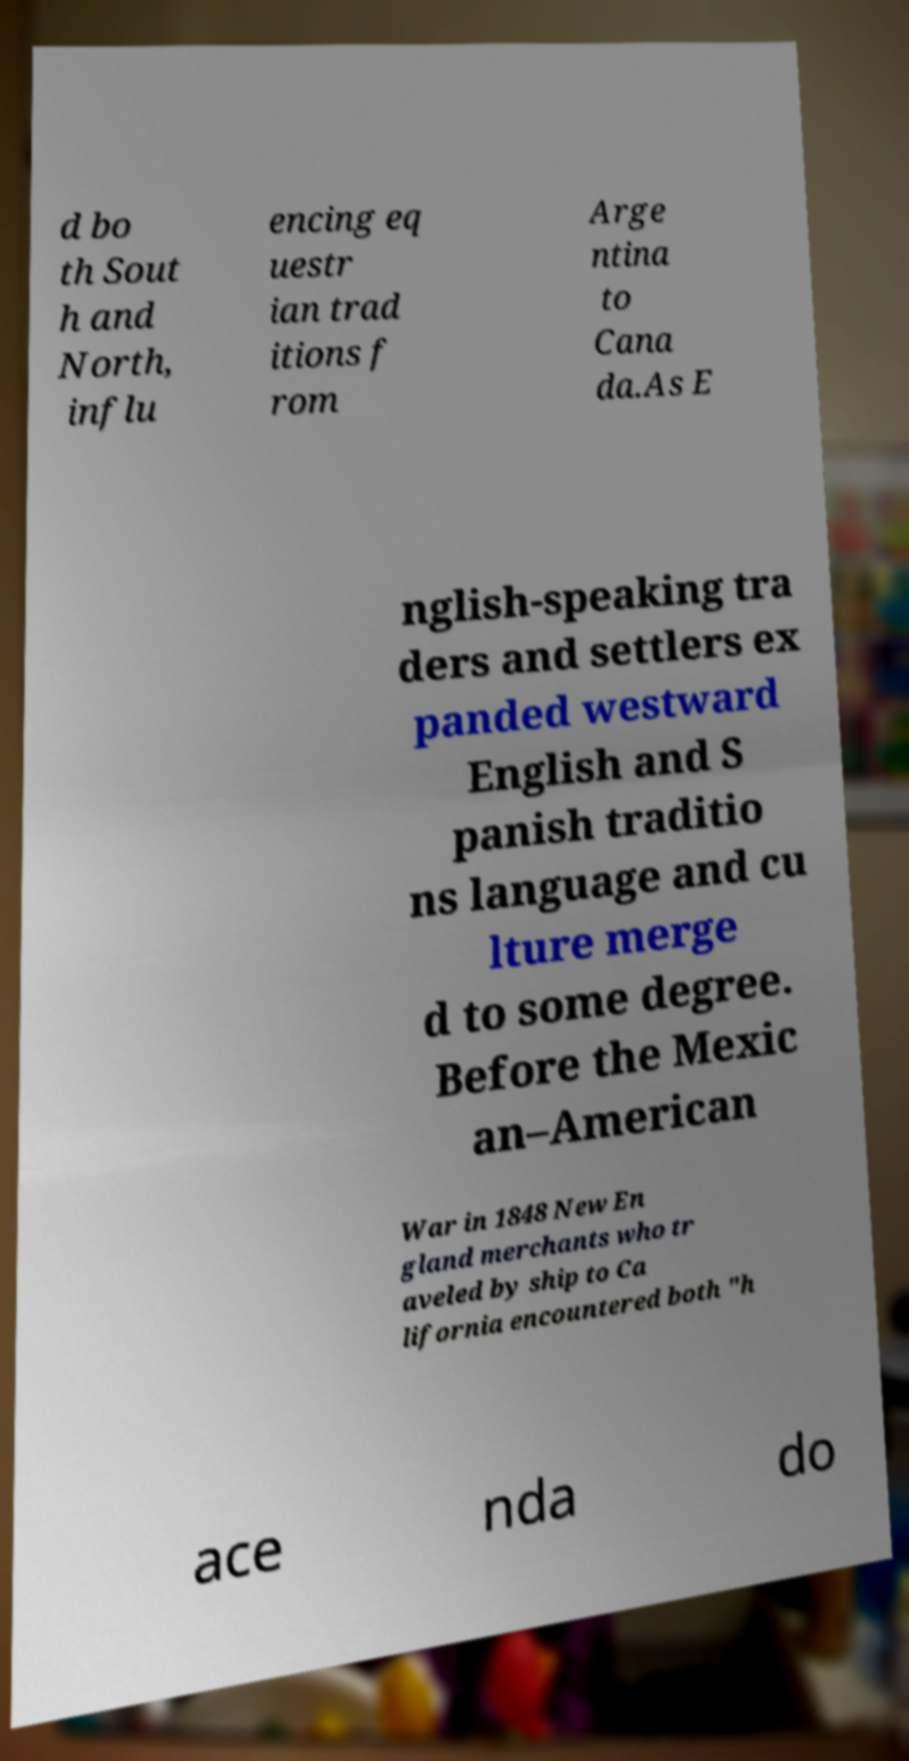Please identify and transcribe the text found in this image. d bo th Sout h and North, influ encing eq uestr ian trad itions f rom Arge ntina to Cana da.As E nglish-speaking tra ders and settlers ex panded westward English and S panish traditio ns language and cu lture merge d to some degree. Before the Mexic an–American War in 1848 New En gland merchants who tr aveled by ship to Ca lifornia encountered both "h ace nda do 